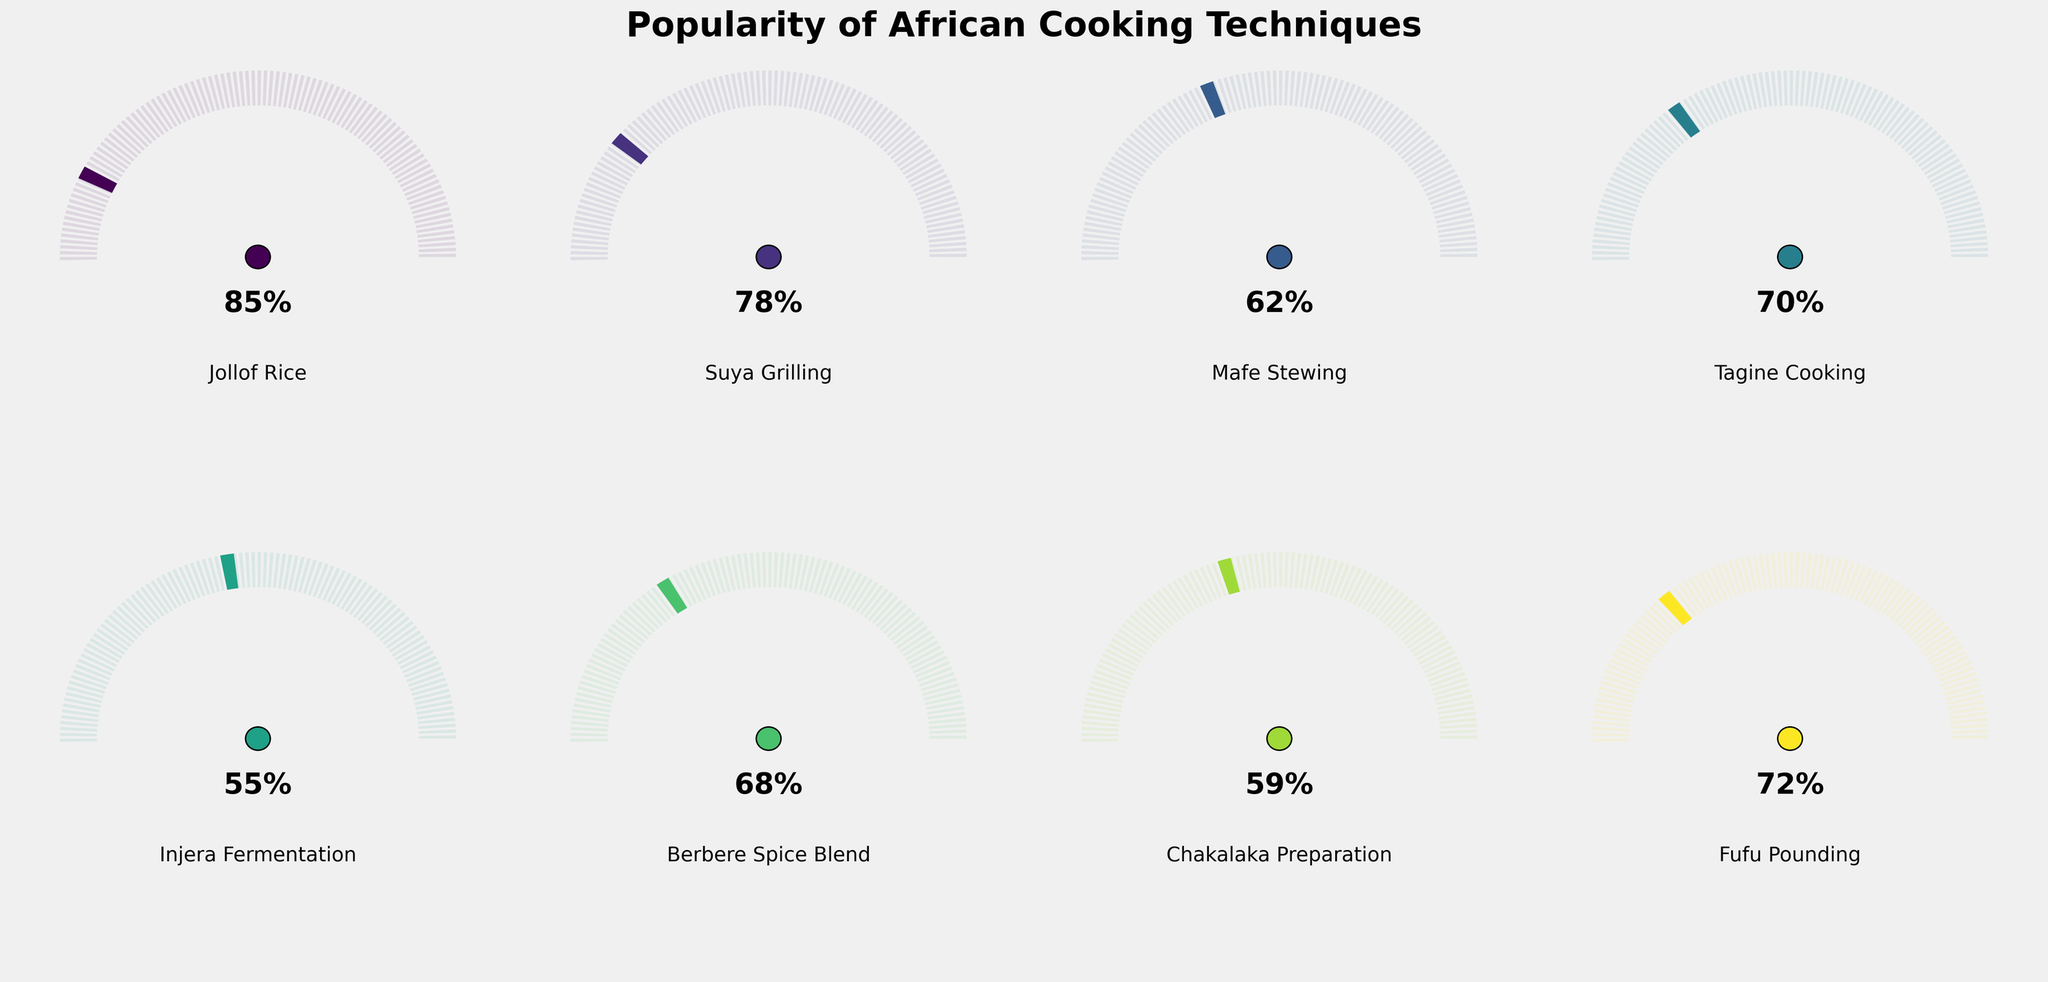Which cooking technique has the highest popularity percentage? According to the figure, the Jollof Rice technique has the highest popularity percentage, as its gauge shows 85%.
Answer: Jollof Rice What is the range of popularities among the listed cooking techniques? By looking at the figure's gauge charts, the popularity values range from 55% to 85%. The lowest value is for Injera Fermentation (55%), and the highest is for Jollof Rice (85%).
Answer: 55% to 85% Which cooking technique is more popular: Suya Grilling or Fufu Pounding? Suya Grilling has a popularity percentage of 78%, while Fufu Pounding has 72%. The gauge chart for Suya Grilling shows a higher value.
Answer: Suya Grilling How many techniques have a popularity of 70% or more? By examining the gauge charts, Jollof Rice (85%), Suya Grilling (78%), Tagine Cooking (70%), and Fufu Pounding (72%) all meet or exceed 70%. This totals four techniques.
Answer: 4 What is the least popular cooking technique according to the data? The least popular technique is Injera Fermentation, with a popularity of 55%, as shown by its gauge chart.
Answer: Injera Fermentation What is the average popularity percentage of all the cooking techniques? Sum the popularity percentages of all techniques (85% + 78% + 62% + 70% + 55% + 68% + 59% + 72%) which equals 549%, then divide by the number of techniques (8). The average popularity is 549% / 8 = 68.625%.
Answer: 68.63% Compare the popularity of Chakalaka Preparation and Berbere Spice Blend. Which one is more popular? Chakalaka Preparation has a popularity of 59%, and Berbere Spice Blend has 68%. The gauge chart indicates Berbere Spice Blend is more popular.
Answer: Berbere Spice Blend What is the median popularity percentage among the listed techniques? Sorting the popularity percentages from lowest to highest (55%, 59%, 62%, 68%, 70%, 72%, 78%, 85%) and finding the middle value: (68% + 70%) / 2 = 69%.
Answer: 69% Which cooking techniques have a popularity between 60% and 70%? From the gauge charts, Mafe Stewing (62%), Berbere Spice Blend (68%), and Chakalaka Preparation (59% is just below 60%) fit this range, though Chakalaka is on the lower borderline.
Answer: Mafe Stewing, Berbere Spice Blend What percentage difference is there between the most and least popular techniques? The most popular technique is Jollof Rice (85%), and the least popular is Injera Fermentation (55%). The difference is 85% - 55% = 30%.
Answer: 30% 